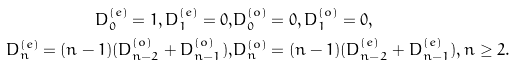<formula> <loc_0><loc_0><loc_500><loc_500>D _ { 0 } ^ { ( e ) } = 1 , D _ { 1 } ^ { ( e ) } = 0 , & D _ { 0 } ^ { ( o ) } = 0 , D _ { 1 } ^ { ( o ) } = 0 , \\ D _ { n } ^ { ( e ) } = ( n - 1 ) ( D _ { n - 2 } ^ { ( o ) } + D _ { n - 1 } ^ { ( o ) } ) , & D _ { n } ^ { ( o ) } = ( n - 1 ) ( D _ { n - 2 } ^ { ( e ) } + D _ { n - 1 } ^ { ( e ) } ) , n \geq 2 .</formula> 